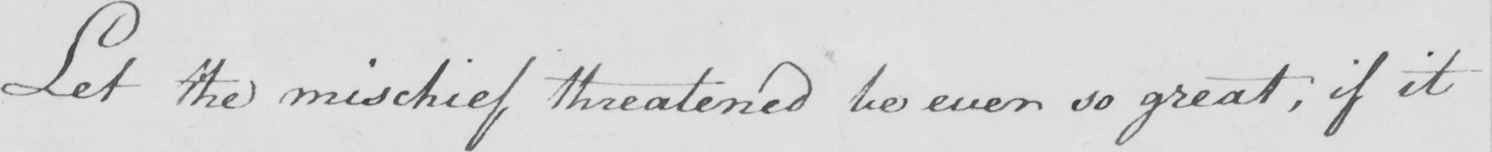What is written in this line of handwriting? Let the mischief threatened be ever so great , if it 